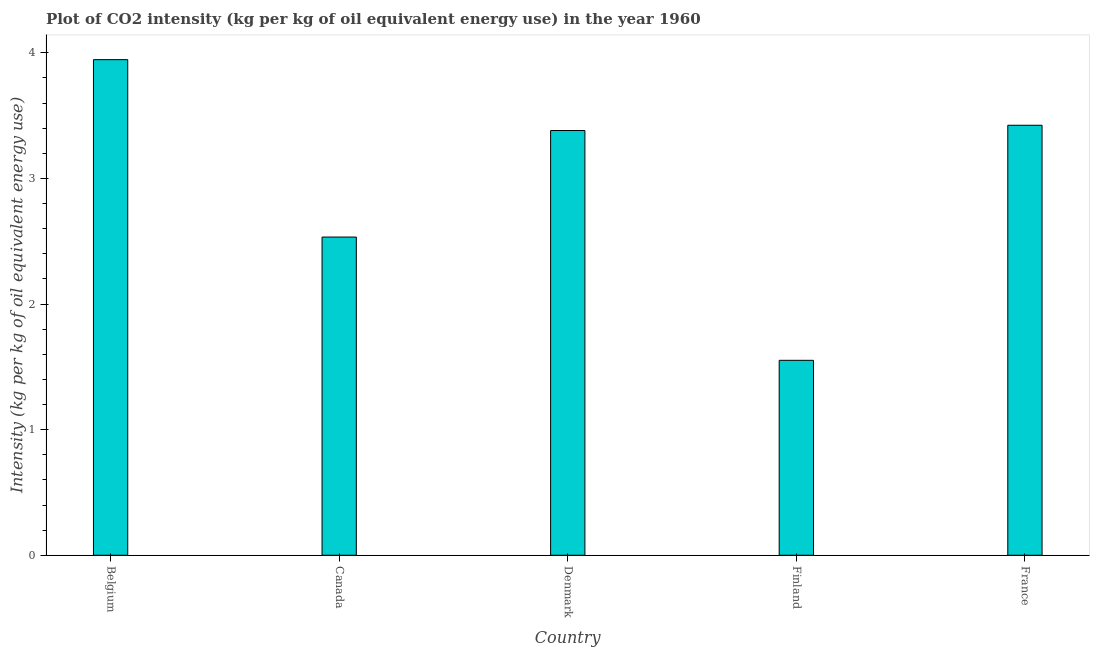Does the graph contain grids?
Your answer should be very brief. No. What is the title of the graph?
Your answer should be very brief. Plot of CO2 intensity (kg per kg of oil equivalent energy use) in the year 1960. What is the label or title of the Y-axis?
Your answer should be compact. Intensity (kg per kg of oil equivalent energy use). What is the co2 intensity in Belgium?
Offer a terse response. 3.95. Across all countries, what is the maximum co2 intensity?
Provide a short and direct response. 3.95. Across all countries, what is the minimum co2 intensity?
Make the answer very short. 1.55. In which country was the co2 intensity maximum?
Keep it short and to the point. Belgium. In which country was the co2 intensity minimum?
Make the answer very short. Finland. What is the sum of the co2 intensity?
Your response must be concise. 14.84. What is the difference between the co2 intensity in Canada and Denmark?
Ensure brevity in your answer.  -0.85. What is the average co2 intensity per country?
Your answer should be very brief. 2.97. What is the median co2 intensity?
Provide a short and direct response. 3.38. In how many countries, is the co2 intensity greater than 0.4 kg?
Your response must be concise. 5. What is the ratio of the co2 intensity in Denmark to that in Finland?
Keep it short and to the point. 2.18. What is the difference between the highest and the second highest co2 intensity?
Your answer should be very brief. 0.52. Is the sum of the co2 intensity in Denmark and Finland greater than the maximum co2 intensity across all countries?
Your answer should be very brief. Yes. What is the difference between the highest and the lowest co2 intensity?
Offer a very short reply. 2.39. In how many countries, is the co2 intensity greater than the average co2 intensity taken over all countries?
Keep it short and to the point. 3. How many bars are there?
Provide a short and direct response. 5. What is the difference between two consecutive major ticks on the Y-axis?
Provide a short and direct response. 1. What is the Intensity (kg per kg of oil equivalent energy use) of Belgium?
Provide a succinct answer. 3.95. What is the Intensity (kg per kg of oil equivalent energy use) of Canada?
Give a very brief answer. 2.53. What is the Intensity (kg per kg of oil equivalent energy use) in Denmark?
Give a very brief answer. 3.38. What is the Intensity (kg per kg of oil equivalent energy use) of Finland?
Your answer should be compact. 1.55. What is the Intensity (kg per kg of oil equivalent energy use) of France?
Your answer should be compact. 3.42. What is the difference between the Intensity (kg per kg of oil equivalent energy use) in Belgium and Canada?
Offer a terse response. 1.41. What is the difference between the Intensity (kg per kg of oil equivalent energy use) in Belgium and Denmark?
Provide a succinct answer. 0.56. What is the difference between the Intensity (kg per kg of oil equivalent energy use) in Belgium and Finland?
Give a very brief answer. 2.39. What is the difference between the Intensity (kg per kg of oil equivalent energy use) in Belgium and France?
Offer a terse response. 0.52. What is the difference between the Intensity (kg per kg of oil equivalent energy use) in Canada and Denmark?
Your answer should be compact. -0.85. What is the difference between the Intensity (kg per kg of oil equivalent energy use) in Canada and Finland?
Make the answer very short. 0.98. What is the difference between the Intensity (kg per kg of oil equivalent energy use) in Canada and France?
Your response must be concise. -0.89. What is the difference between the Intensity (kg per kg of oil equivalent energy use) in Denmark and Finland?
Give a very brief answer. 1.83. What is the difference between the Intensity (kg per kg of oil equivalent energy use) in Denmark and France?
Offer a very short reply. -0.04. What is the difference between the Intensity (kg per kg of oil equivalent energy use) in Finland and France?
Keep it short and to the point. -1.87. What is the ratio of the Intensity (kg per kg of oil equivalent energy use) in Belgium to that in Canada?
Provide a succinct answer. 1.56. What is the ratio of the Intensity (kg per kg of oil equivalent energy use) in Belgium to that in Denmark?
Give a very brief answer. 1.17. What is the ratio of the Intensity (kg per kg of oil equivalent energy use) in Belgium to that in Finland?
Make the answer very short. 2.54. What is the ratio of the Intensity (kg per kg of oil equivalent energy use) in Belgium to that in France?
Make the answer very short. 1.15. What is the ratio of the Intensity (kg per kg of oil equivalent energy use) in Canada to that in Denmark?
Make the answer very short. 0.75. What is the ratio of the Intensity (kg per kg of oil equivalent energy use) in Canada to that in Finland?
Your answer should be compact. 1.63. What is the ratio of the Intensity (kg per kg of oil equivalent energy use) in Canada to that in France?
Offer a terse response. 0.74. What is the ratio of the Intensity (kg per kg of oil equivalent energy use) in Denmark to that in Finland?
Give a very brief answer. 2.18. What is the ratio of the Intensity (kg per kg of oil equivalent energy use) in Finland to that in France?
Provide a short and direct response. 0.45. 